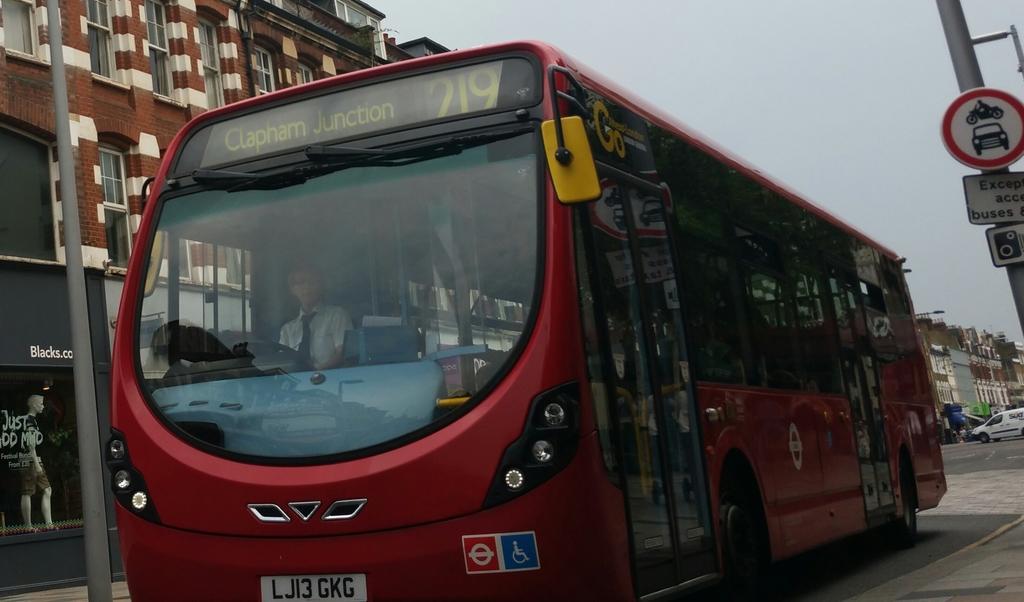How would you summarize this image in a sentence or two? In this image we can see a person sitting in the vehicle and we can also see buildings, poles, vehicles and boards with some text. 